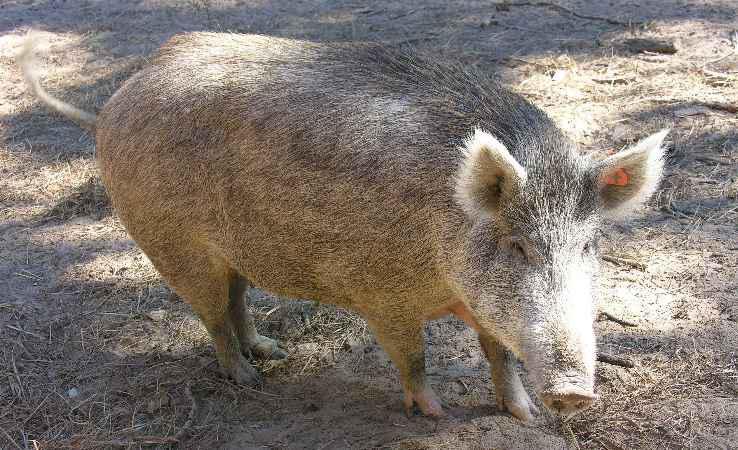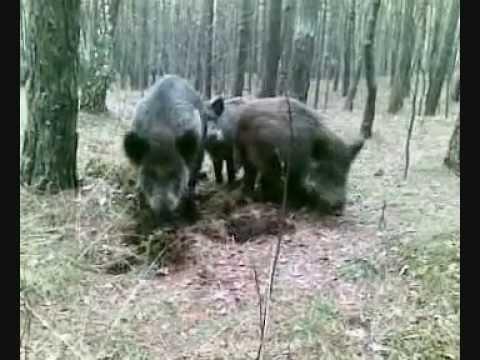The first image is the image on the left, the second image is the image on the right. For the images displayed, is the sentence "There are at least two striped baby hogs standing next to a black adult hog." factually correct? Answer yes or no. No. The first image is the image on the left, the second image is the image on the right. Examine the images to the left and right. Is the description "The combined images include at least three piglets standing on all fours, and all piglets are near a standing adult pig." accurate? Answer yes or no. No. 